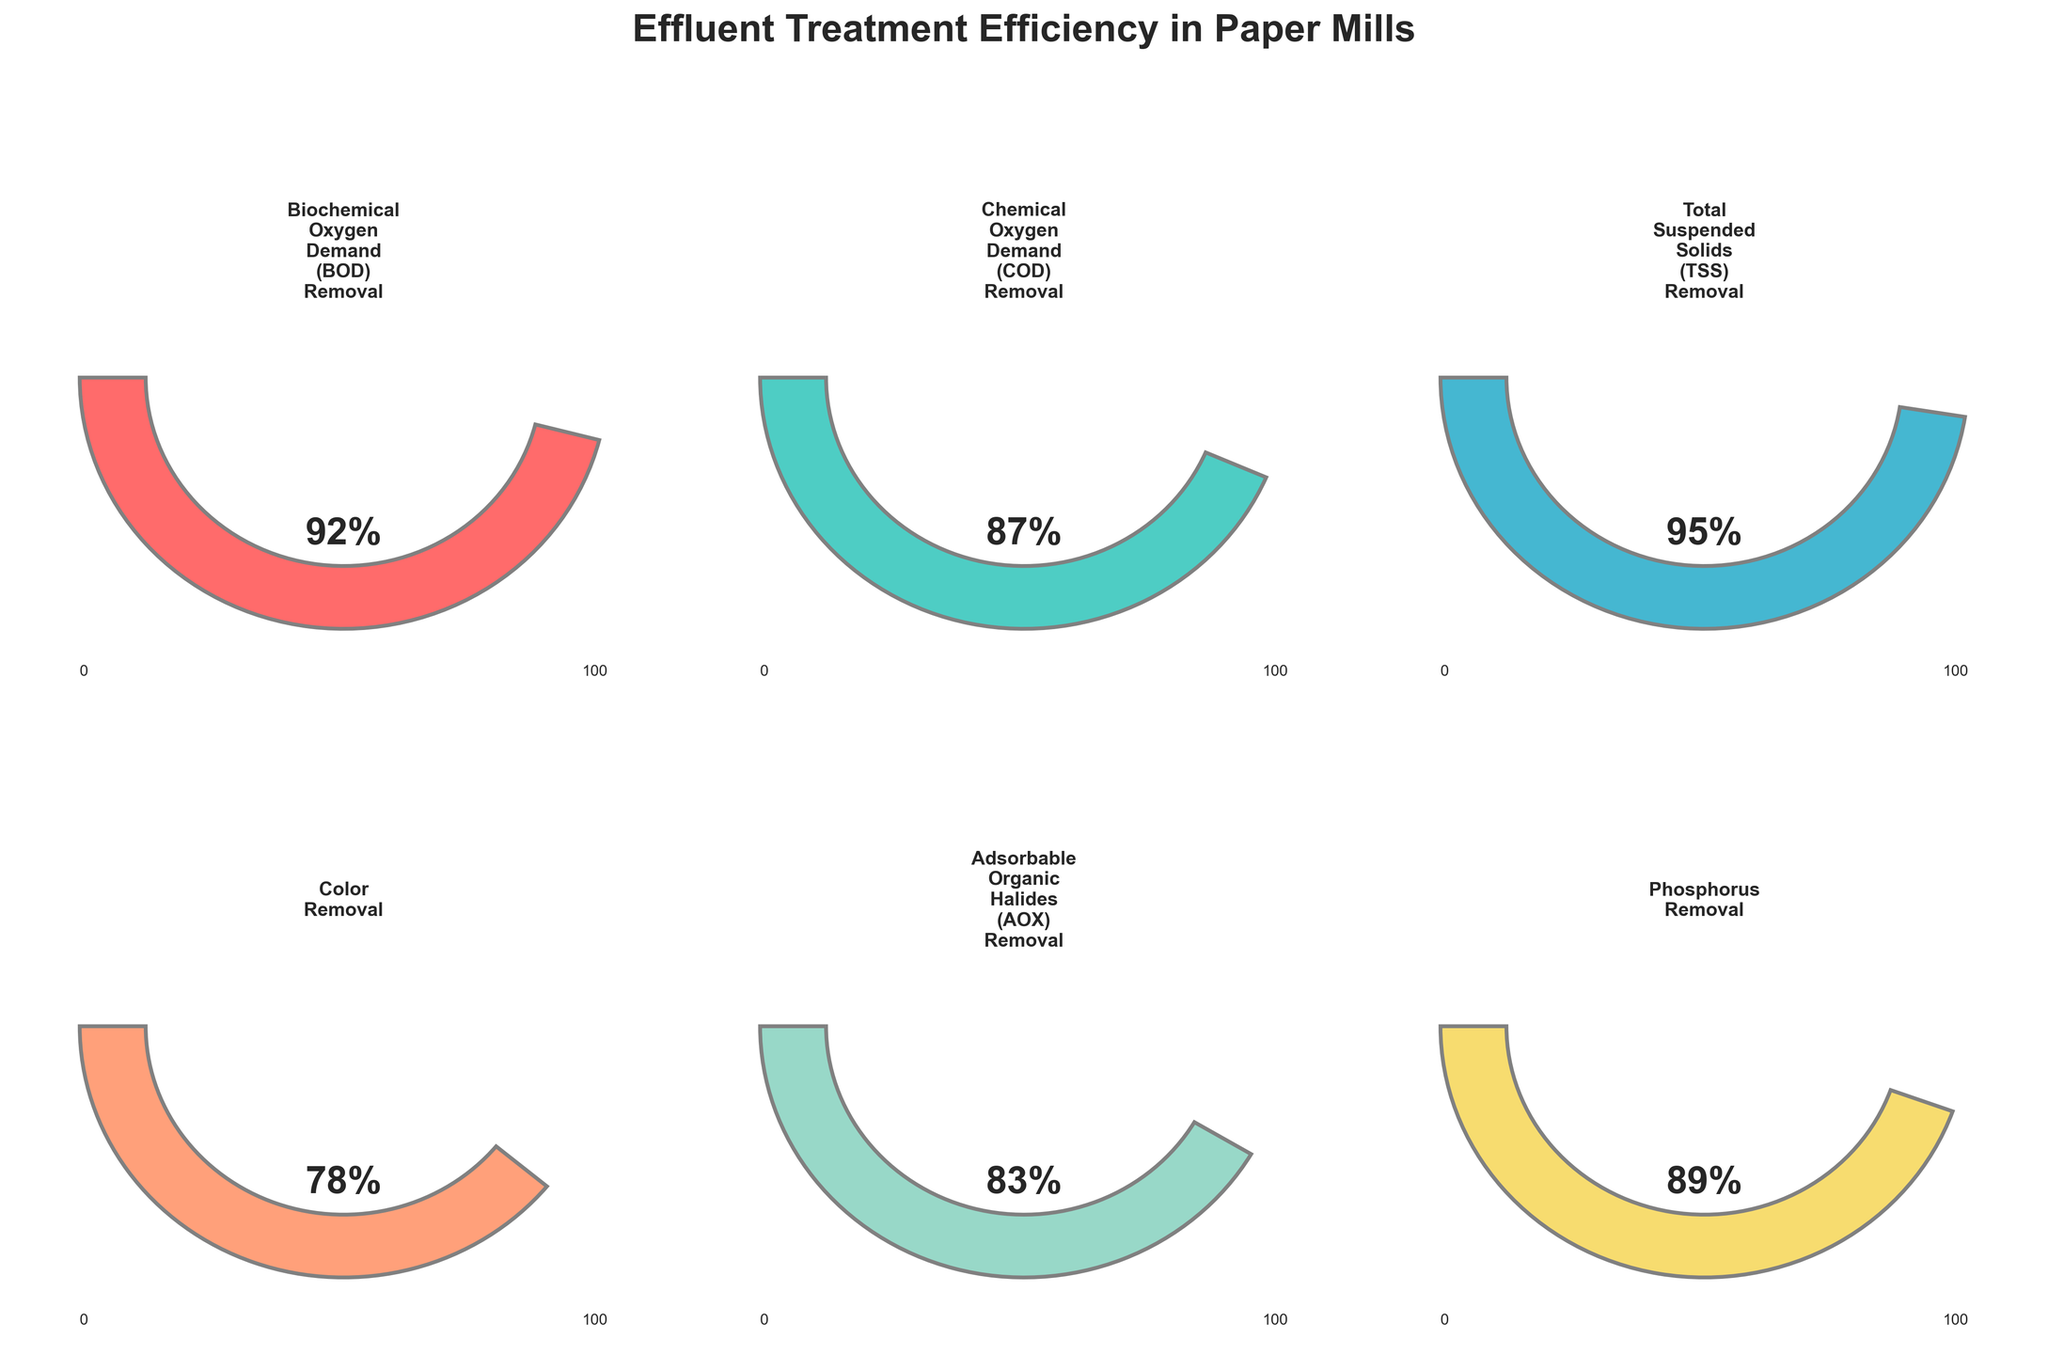Which parameter shows the highest removal percentage? Review all the gauge charts and identify the one with the highest value. Total Suspended Solids (TSS) Removal has a value of 95%, which is the highest.
Answer: Total Suspended Solids (TSS) Removal Which parameter shows the lowest removal percentage? Review all the gauge charts and identify the one with the lowest value. Color Removal has a value of 78%, which is the lowest.
Answer: Color Removal What is the title of the figure? Observe the figure and read the title displayed at the top. The title is "Effluent Treatment Efficiency in Paper Mills."
Answer: Effluent Treatment Efficiency in Paper Mills How many parameters are displayed in the figure? Count the number of individual gauge charts presented in the figure. There are 6 parameters shown.
Answer: 6 Which parameters have a removal percentage greater than 90%? Review each gauge chart and note down the parameters with values above 90%. Both Biochemical Oxygen Demand (BOD) Removal and Total Suspended Solids (TSS) Removal have values greater than 90%.
Answer: Biochemical Oxygen Demand (BOD) Removal and Total Suspended Solids (TSS) Removal What is the difference between the highest and lowest removal percentages? Identify the highest (95% for TSS Removal) and lowest (78% for Color Removal) values and calculate their difference. The difference is 95% - 78% = 17%.
Answer: 17% How much higher is the Phosphorus Removal percentage compared to Color Removal? Find the values for Phosphorus Removal (89%) and Color Removal (78%) and calculate the difference. The difference is 89% - 78% = 11%.
Answer: 11% Which parameter is closest to achieving a 100% removal rate? Compare each gauge chart value to 100 and identify the one with the smallest difference. Total Suspended Solids (TSS) Removal is closest with a value of 95%.
Answer: Total Suspended Solids (TSS) Removal What is the average removal percentage across all parameters? Sum the percentages of all parameters and divide by the number of parameters. (92% + 87% + 95% + 78% + 83% + 89%) / 6 = 87.33%
Answer: 87.33% 